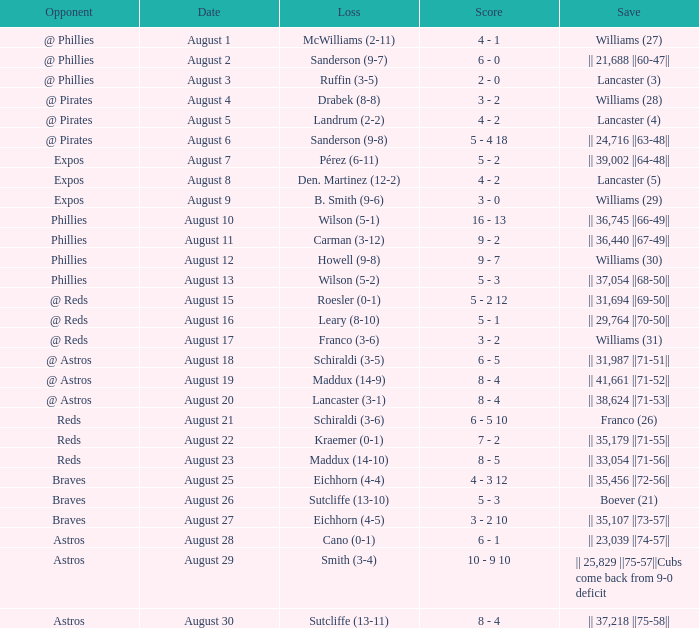Name the date for loss of ruffin (3-5) August 3. 